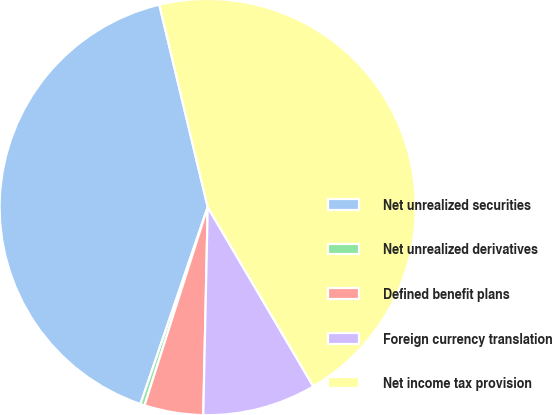<chart> <loc_0><loc_0><loc_500><loc_500><pie_chart><fcel>Net unrealized securities<fcel>Net unrealized derivatives<fcel>Defined benefit plans<fcel>Foreign currency translation<fcel>Net income tax provision<nl><fcel>41.03%<fcel>0.33%<fcel>4.57%<fcel>8.81%<fcel>45.27%<nl></chart> 